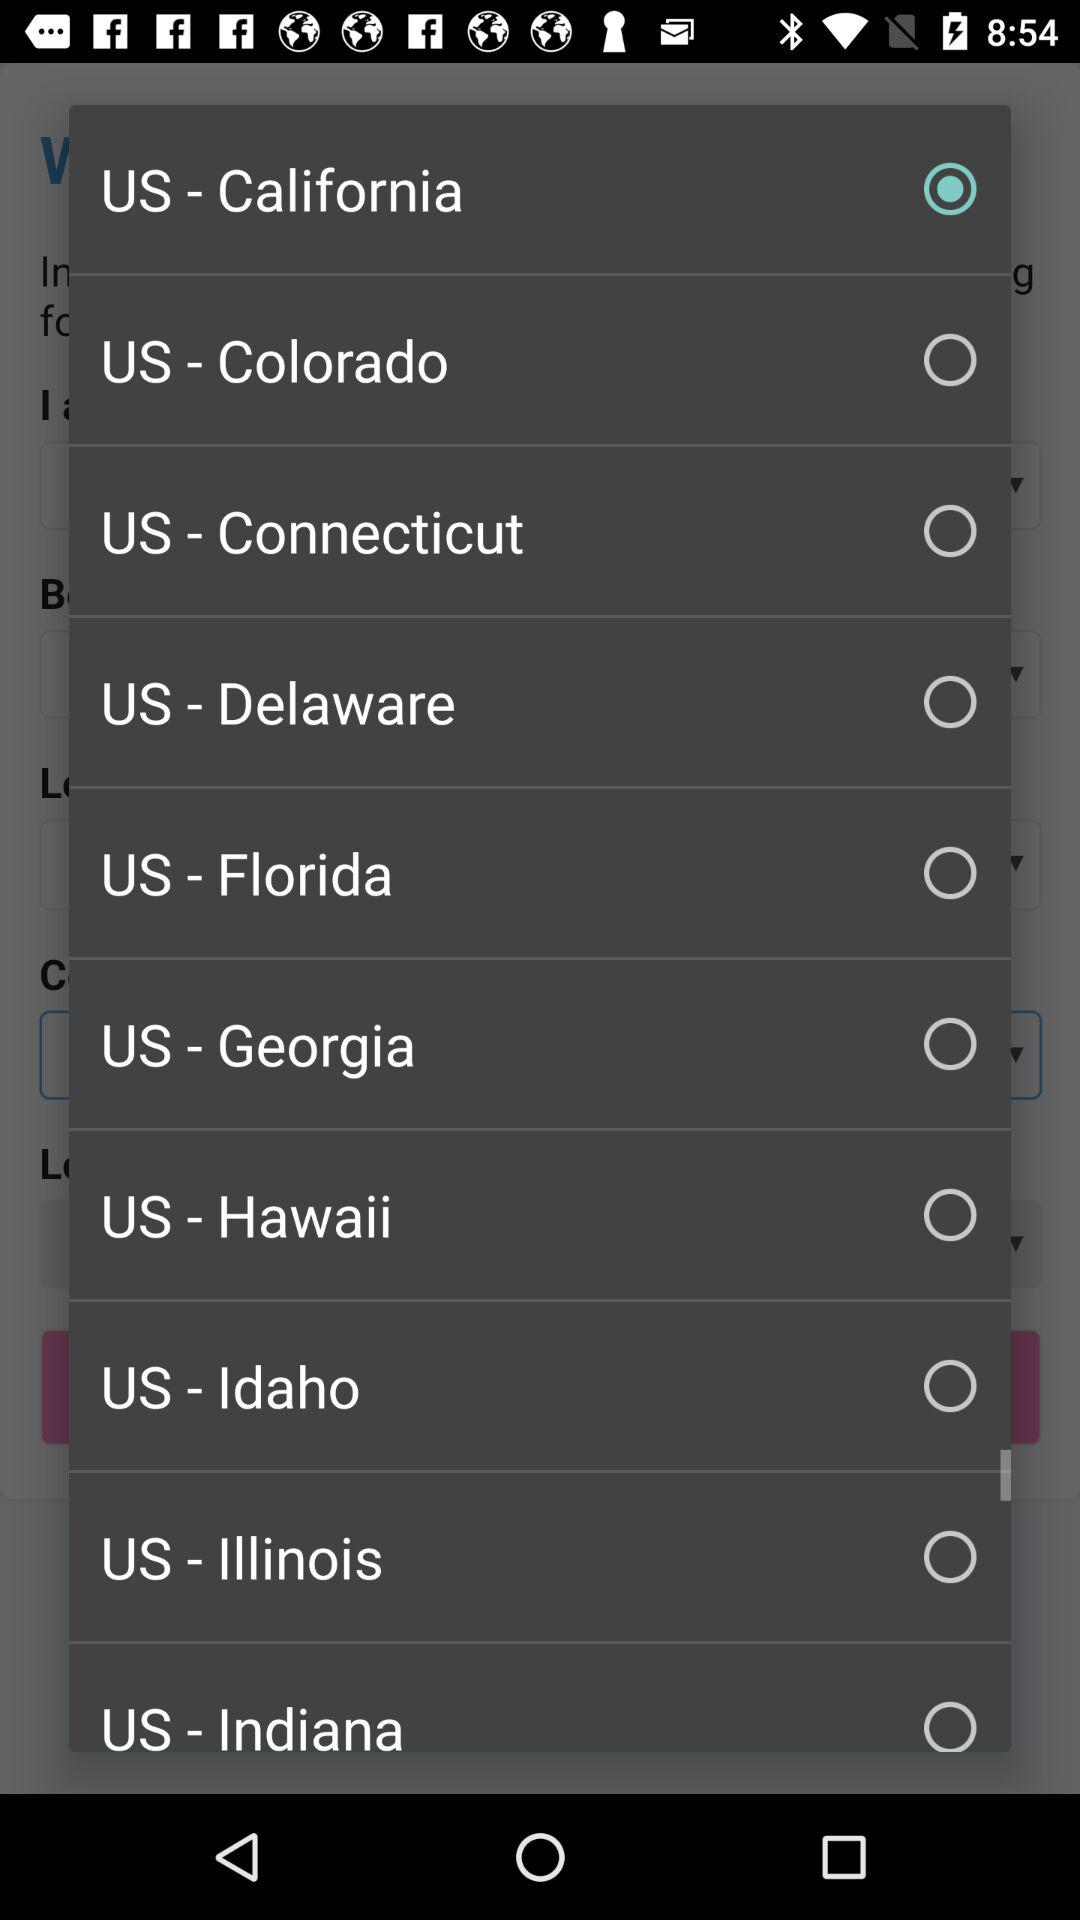Which state is selected? The selected state is California. 